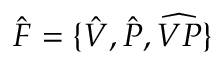<formula> <loc_0><loc_0><loc_500><loc_500>\hat { F } = \{ \hat { V } , \hat { P } , \widehat { V P } \}</formula> 